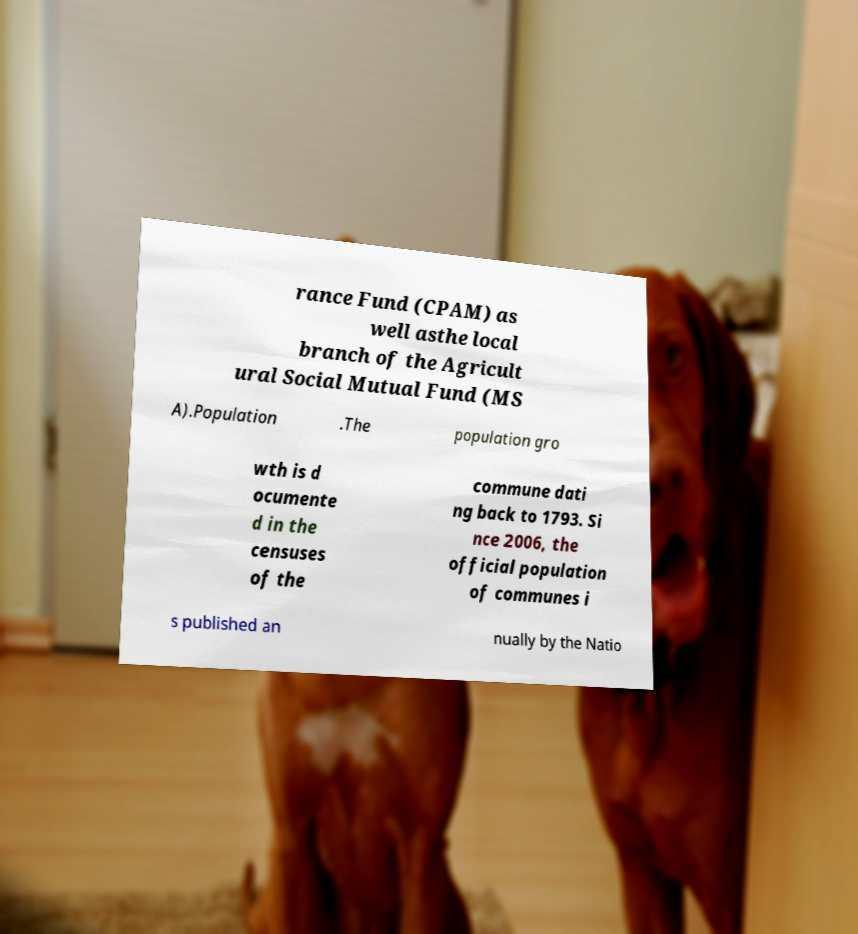Can you read and provide the text displayed in the image?This photo seems to have some interesting text. Can you extract and type it out for me? rance Fund (CPAM) as well asthe local branch of the Agricult ural Social Mutual Fund (MS A).Population .The population gro wth is d ocumente d in the censuses of the commune dati ng back to 1793. Si nce 2006, the official population of communes i s published an nually by the Natio 